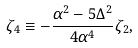<formula> <loc_0><loc_0><loc_500><loc_500>\zeta _ { 4 } \equiv - \frac { \alpha ^ { 2 } - 5 \Delta ^ { 2 } } { 4 \alpha ^ { 4 } } \zeta _ { 2 } ,</formula> 